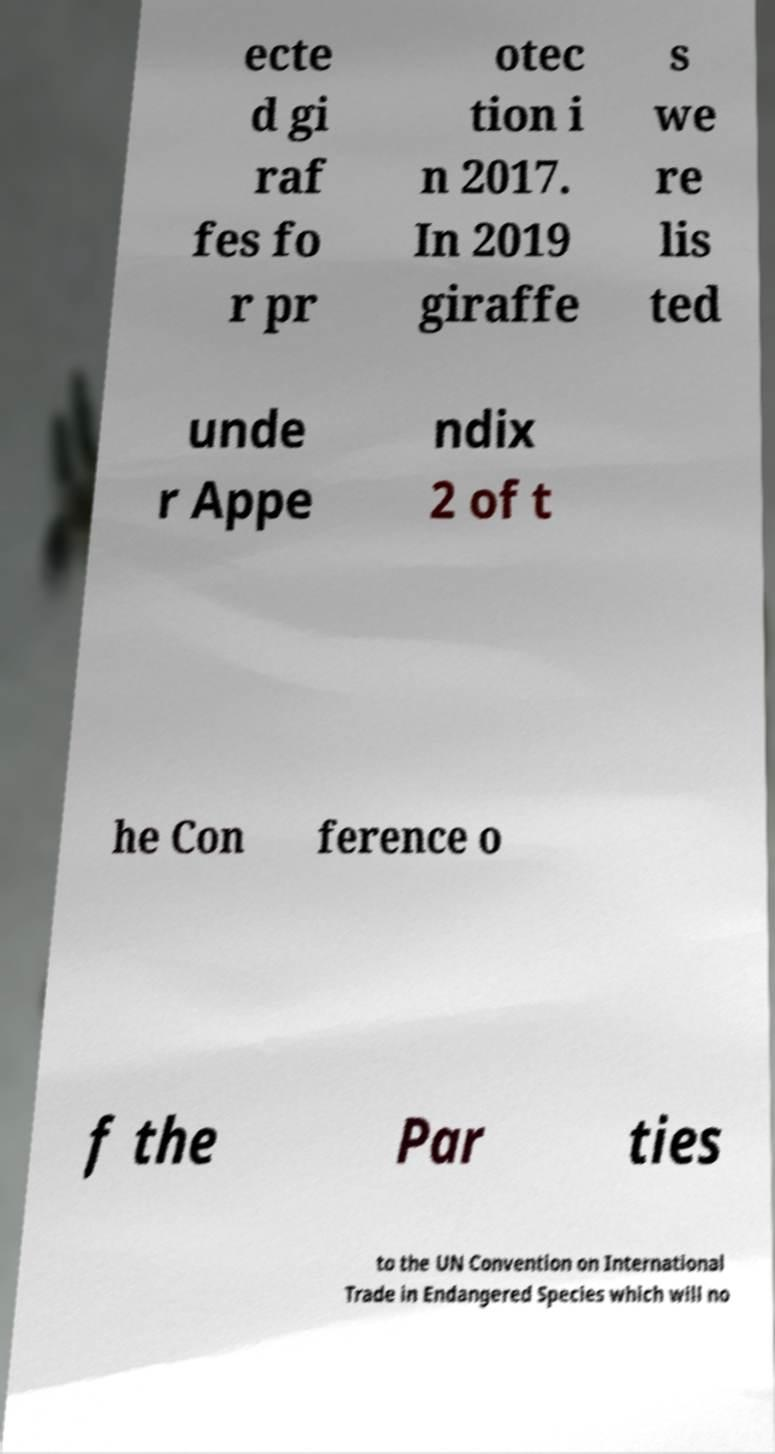I need the written content from this picture converted into text. Can you do that? ecte d gi raf fes fo r pr otec tion i n 2017. In 2019 giraffe s we re lis ted unde r Appe ndix 2 of t he Con ference o f the Par ties to the UN Convention on International Trade in Endangered Species which will no 